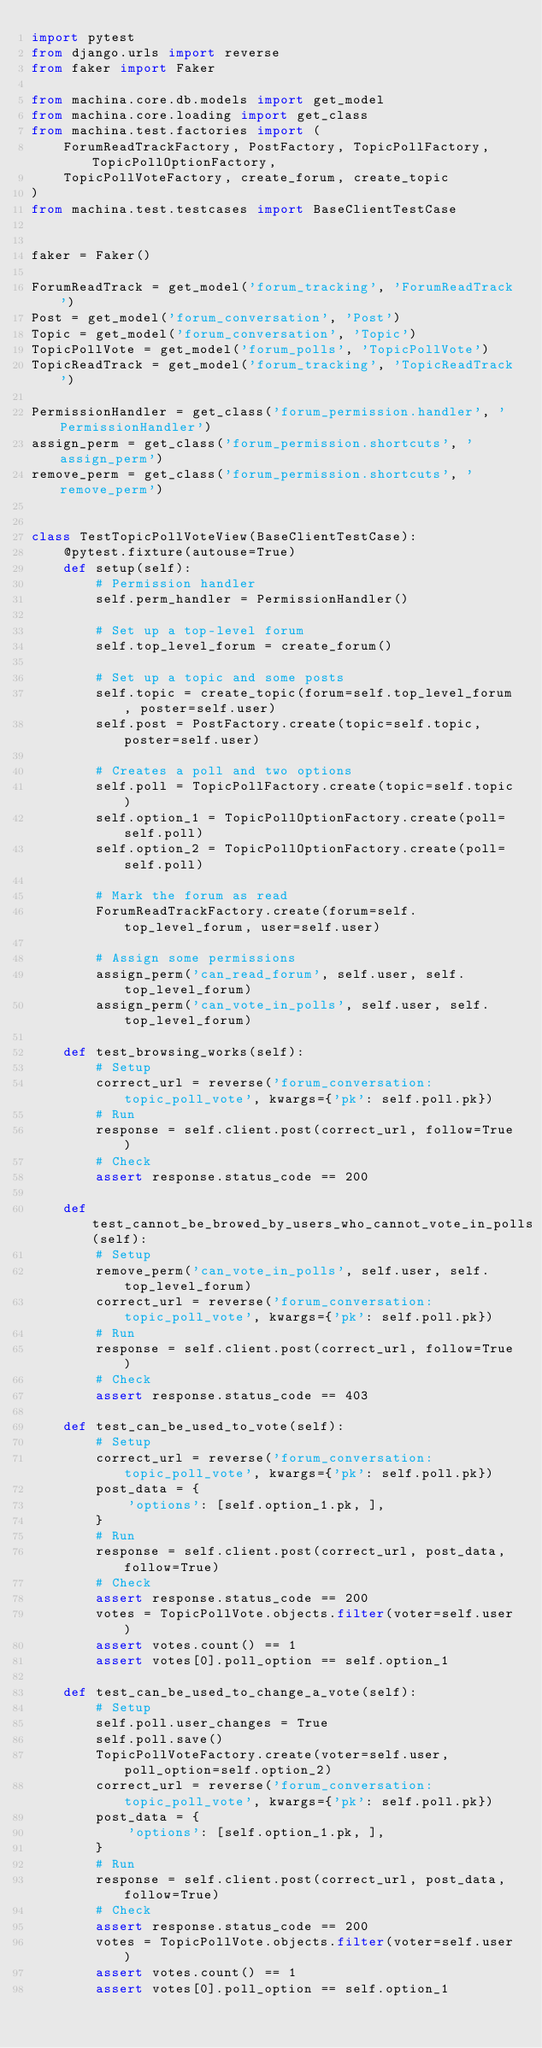Convert code to text. <code><loc_0><loc_0><loc_500><loc_500><_Python_>import pytest
from django.urls import reverse
from faker import Faker

from machina.core.db.models import get_model
from machina.core.loading import get_class
from machina.test.factories import (
    ForumReadTrackFactory, PostFactory, TopicPollFactory, TopicPollOptionFactory,
    TopicPollVoteFactory, create_forum, create_topic
)
from machina.test.testcases import BaseClientTestCase


faker = Faker()

ForumReadTrack = get_model('forum_tracking', 'ForumReadTrack')
Post = get_model('forum_conversation', 'Post')
Topic = get_model('forum_conversation', 'Topic')
TopicPollVote = get_model('forum_polls', 'TopicPollVote')
TopicReadTrack = get_model('forum_tracking', 'TopicReadTrack')

PermissionHandler = get_class('forum_permission.handler', 'PermissionHandler')
assign_perm = get_class('forum_permission.shortcuts', 'assign_perm')
remove_perm = get_class('forum_permission.shortcuts', 'remove_perm')


class TestTopicPollVoteView(BaseClientTestCase):
    @pytest.fixture(autouse=True)
    def setup(self):
        # Permission handler
        self.perm_handler = PermissionHandler()

        # Set up a top-level forum
        self.top_level_forum = create_forum()

        # Set up a topic and some posts
        self.topic = create_topic(forum=self.top_level_forum, poster=self.user)
        self.post = PostFactory.create(topic=self.topic, poster=self.user)

        # Creates a poll and two options
        self.poll = TopicPollFactory.create(topic=self.topic)
        self.option_1 = TopicPollOptionFactory.create(poll=self.poll)
        self.option_2 = TopicPollOptionFactory.create(poll=self.poll)

        # Mark the forum as read
        ForumReadTrackFactory.create(forum=self.top_level_forum, user=self.user)

        # Assign some permissions
        assign_perm('can_read_forum', self.user, self.top_level_forum)
        assign_perm('can_vote_in_polls', self.user, self.top_level_forum)

    def test_browsing_works(self):
        # Setup
        correct_url = reverse('forum_conversation:topic_poll_vote', kwargs={'pk': self.poll.pk})
        # Run
        response = self.client.post(correct_url, follow=True)
        # Check
        assert response.status_code == 200

    def test_cannot_be_browed_by_users_who_cannot_vote_in_polls(self):
        # Setup
        remove_perm('can_vote_in_polls', self.user, self.top_level_forum)
        correct_url = reverse('forum_conversation:topic_poll_vote', kwargs={'pk': self.poll.pk})
        # Run
        response = self.client.post(correct_url, follow=True)
        # Check
        assert response.status_code == 403

    def test_can_be_used_to_vote(self):
        # Setup
        correct_url = reverse('forum_conversation:topic_poll_vote', kwargs={'pk': self.poll.pk})
        post_data = {
            'options': [self.option_1.pk, ],
        }
        # Run
        response = self.client.post(correct_url, post_data, follow=True)
        # Check
        assert response.status_code == 200
        votes = TopicPollVote.objects.filter(voter=self.user)
        assert votes.count() == 1
        assert votes[0].poll_option == self.option_1

    def test_can_be_used_to_change_a_vote(self):
        # Setup
        self.poll.user_changes = True
        self.poll.save()
        TopicPollVoteFactory.create(voter=self.user, poll_option=self.option_2)
        correct_url = reverse('forum_conversation:topic_poll_vote', kwargs={'pk': self.poll.pk})
        post_data = {
            'options': [self.option_1.pk, ],
        }
        # Run
        response = self.client.post(correct_url, post_data, follow=True)
        # Check
        assert response.status_code == 200
        votes = TopicPollVote.objects.filter(voter=self.user)
        assert votes.count() == 1
        assert votes[0].poll_option == self.option_1
</code> 